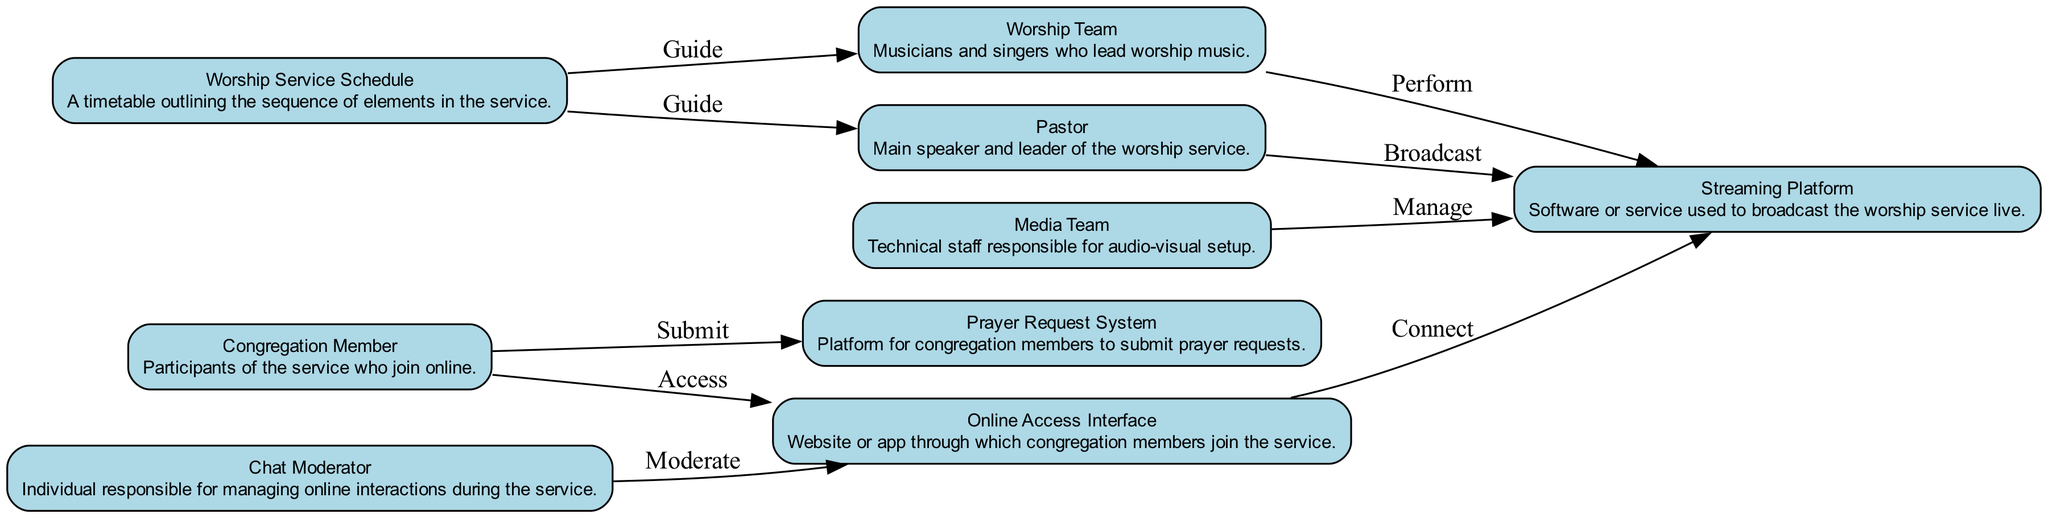What is the total number of nodes in the diagram? The diagram contains nodes for each element listed in the data. There are 9 unique elements: Congregation Member, Pastor, Worship Team, Media Team, Streaming Platform, Online Access Interface, Chat Moderator, Prayer Request System, and Worship Service Schedule.
Answer: 9 Which node connects to the Streaming Platform after the Online Access Interface? According to the diagram, the next node connected to the Streaming Platform from the Online Access Interface is the Pastor. This is indicated by the edge leading from the Online Access Interface to the Streaming Platform labeled 'Connect', then another edge from the Pastor to the Streaming Platform labeled 'Broadcast'.
Answer: Pastor Which team is responsible for managing the Streaming Platform? The diagram indicates that the Media Team is responsible for managing the Streaming Platform, as shown by the edge labeled 'Manage' pointing from the Media Team to the Streaming Platform.
Answer: Media Team How many interactions or edges are there in total between the nodes? To determine the total interactions, we analyze the edges represented in the diagram. There are 8 edges connecting various nodes. These edges represent the actions between the elements detailed in the workflow.
Answer: 8 Who guides the Worship Team in the service? The Worship Service Schedule guides the Worship Team, as evidenced by the directed edge indicating 'Guide' from the Worship Service Schedule to the Worship Team.
Answer: Worship Service Schedule What action do congregation members perform related to prayer requests? Congregation members submit prayer requests through the Prayer Request System, which is indicated by the connecting edge labeled 'Submit' that goes from the Congregation Member to the Prayer Request System.
Answer: Submit Which role moderates the Online Access Interface? The Chat Moderator is responsible for moderating the Online Access Interface, as indicated by the edge 'Moderate' pointing from the Chat Moderator to the Online Access Interface in the diagram.
Answer: Chat Moderator From which node does the Worship Team receive guidance? The Worship Team receives guidance from the Worship Service Schedule, which is illustrated by the edge labeled 'Guide' pointing from the Worship Service Schedule to the Worship Team.
Answer: Worship Service Schedule What is the flow of actions starting from the Congregation Member to the Streaming Platform? The flow starts with the Congregation Member accessing the Online Access Interface, which connects to the Streaming Platform. This shows the progression of interactions from the congregation member through the interface to the streaming service.
Answer: Access, Connect 